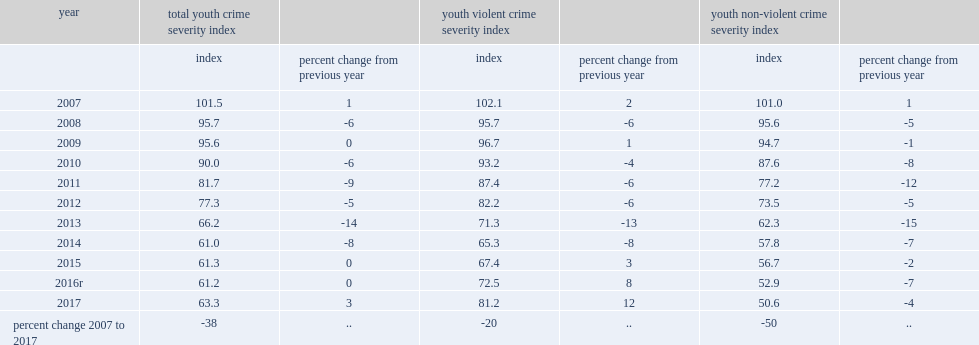What was the percent change in the youth violent csi from previous year in 2017? 12.0. What was the percent change in the youth non-violent csi from previous year in 2017? -4.0. Can you give me this table as a dict? {'header': ['year', 'total youth crime severity index', '', 'youth violent crime severity index', '', 'youth non-violent crime severity index', ''], 'rows': [['', 'index', 'percent change from previous year', 'index', 'percent change from previous year', 'index', 'percent change from previous year'], ['2007', '101.5', '1', '102.1', '2', '101.0', '1'], ['2008', '95.7', '-6', '95.7', '-6', '95.6', '-5'], ['2009', '95.6', '0', '96.7', '1', '94.7', '-1'], ['2010', '90.0', '-6', '93.2', '-4', '87.6', '-8'], ['2011', '81.7', '-9', '87.4', '-6', '77.2', '-12'], ['2012', '77.3', '-5', '82.2', '-6', '73.5', '-5'], ['2013', '66.2', '-14', '71.3', '-13', '62.3', '-15'], ['2014', '61.0', '-8', '65.3', '-8', '57.8', '-7'], ['2015', '61.3', '0', '67.4', '3', '56.7', '-2'], ['2016r', '61.2', '0', '72.5', '8', '52.9', '-7'], ['2017', '63.3', '3', '81.2', '12', '50.6', '-4'], ['percent change 2007 to 2017', '-38', '..', '-20', '..', '-50', '..']]} 